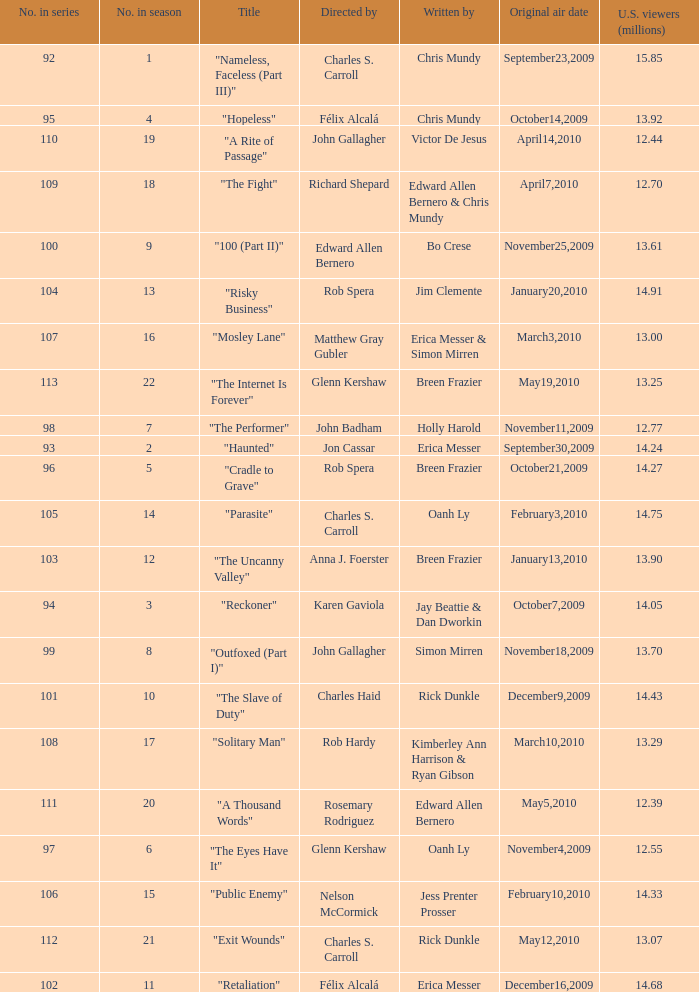What number(s) in the series was written by bo crese? 100.0. 